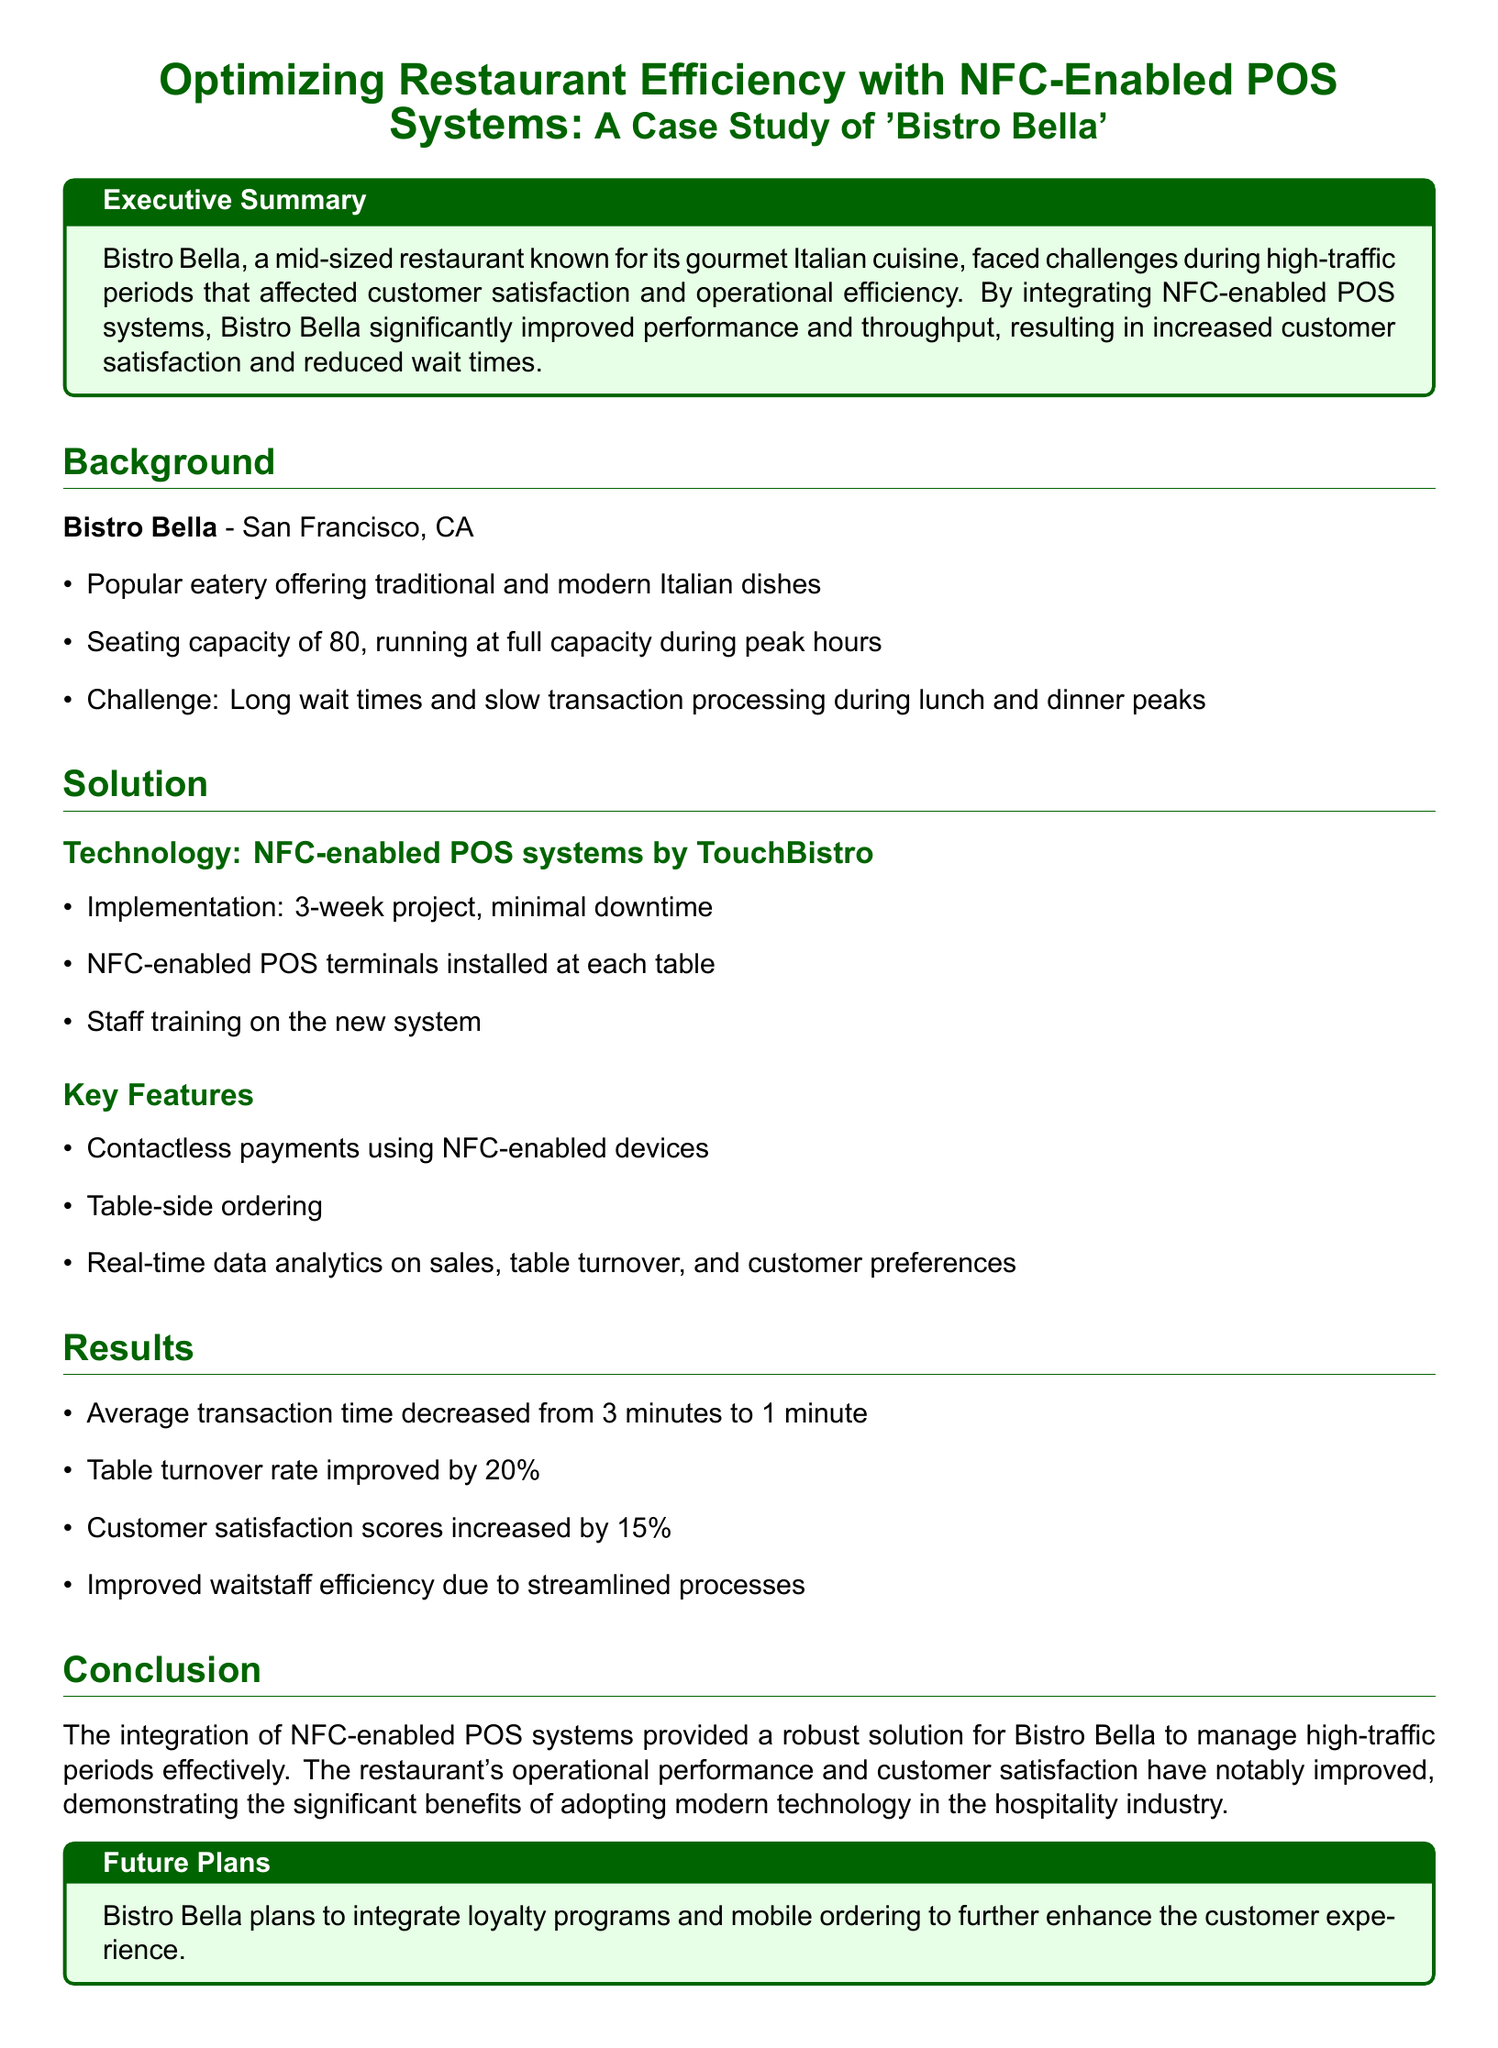What challenges did Bistro Bella face during peak hours? Bistro Bella experienced long wait times and slow transaction processing during lunch and dinner peaks.
Answer: Long wait times and slow transaction processing What technology did Bistro Bella integrate? The document states that Bistro Bella implemented NFC-enabled POS systems by TouchBistro.
Answer: NFC-enabled POS systems by TouchBistro How long did the implementation project take? The document mentions a 3-week project for implementation.
Answer: 3 weeks By what percentage did the table turnover rate improve? The results detail that the table turnover rate improved by 20 percent.
Answer: 20% What was the average transaction time before the integration? The document states that the average transaction time decreased from 3 minutes to 1 minute, indicating it was originally 3 minutes.
Answer: 3 minutes How much did customer satisfaction scores increase? The results indicate that customer satisfaction scores increased by 15 percent.
Answer: 15% What is one of the future plans for Bistro Bella? The document outlines that Bistro Bella plans to integrate loyalty programs and mobile ordering.
Answer: Loyalty programs and mobile ordering What are two key features of the NFC-enabled POS system? Two key features mentioned are contactless payments and table-side ordering.
Answer: Contactless payments, table-side ordering What seating capacity does Bistro Bella have? The background section states that Bistro Bella has a seating capacity of 80.
Answer: 80 